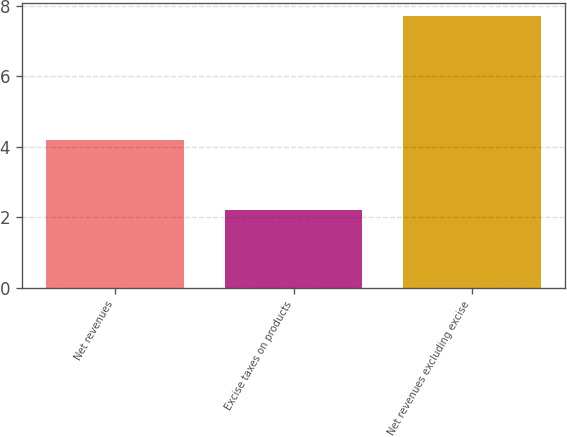Convert chart. <chart><loc_0><loc_0><loc_500><loc_500><bar_chart><fcel>Net revenues<fcel>Excise taxes on products<fcel>Net revenues excluding excise<nl><fcel>4.2<fcel>2.2<fcel>7.7<nl></chart> 